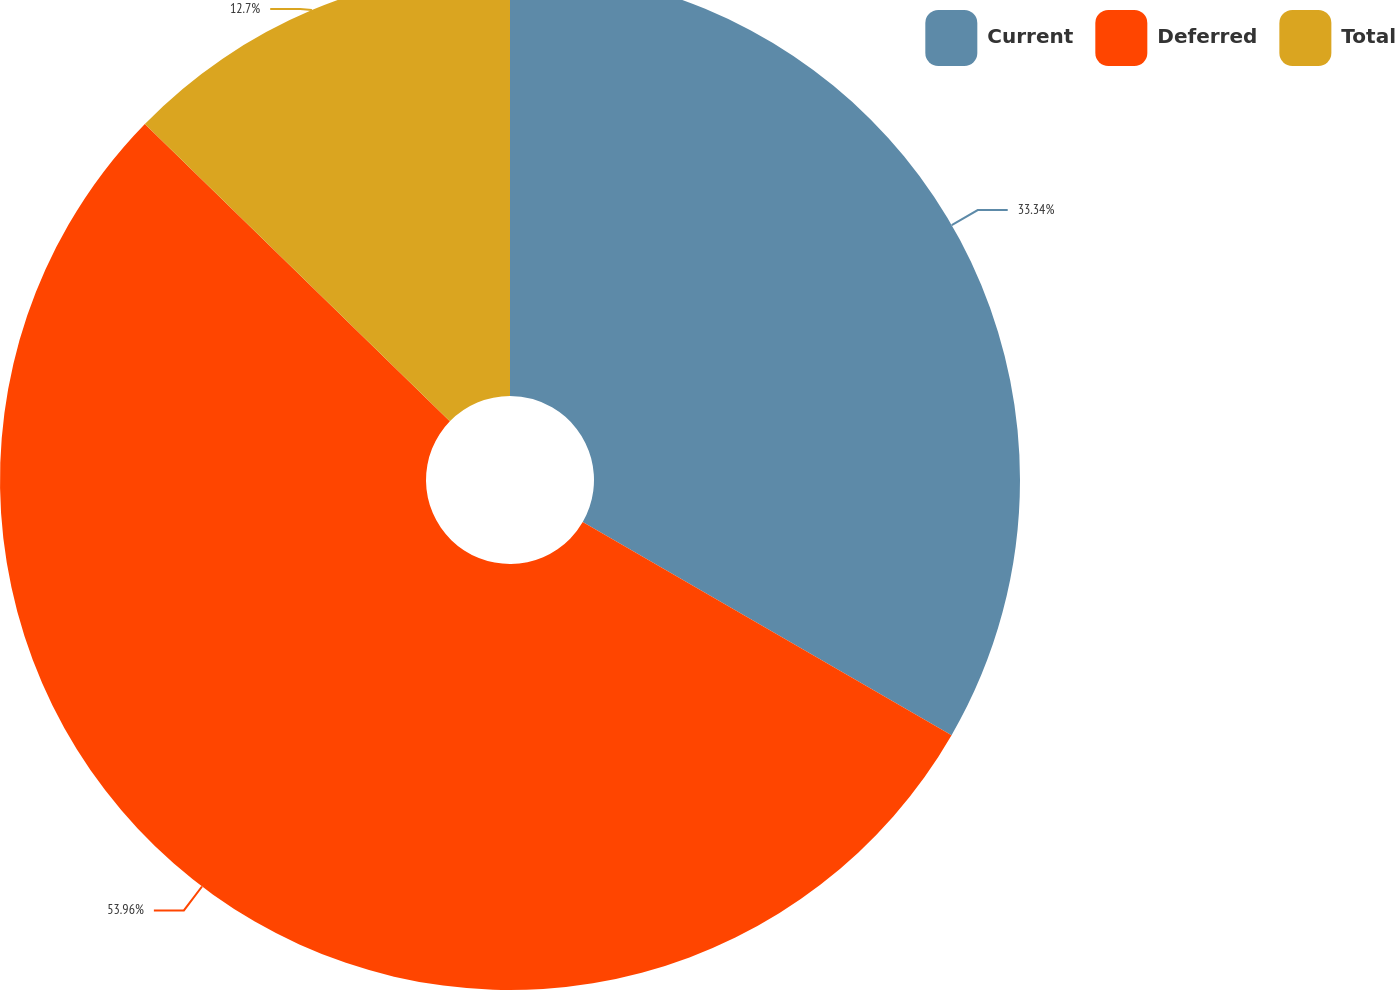<chart> <loc_0><loc_0><loc_500><loc_500><pie_chart><fcel>Current<fcel>Deferred<fcel>Total<nl><fcel>33.34%<fcel>53.96%<fcel>12.7%<nl></chart> 